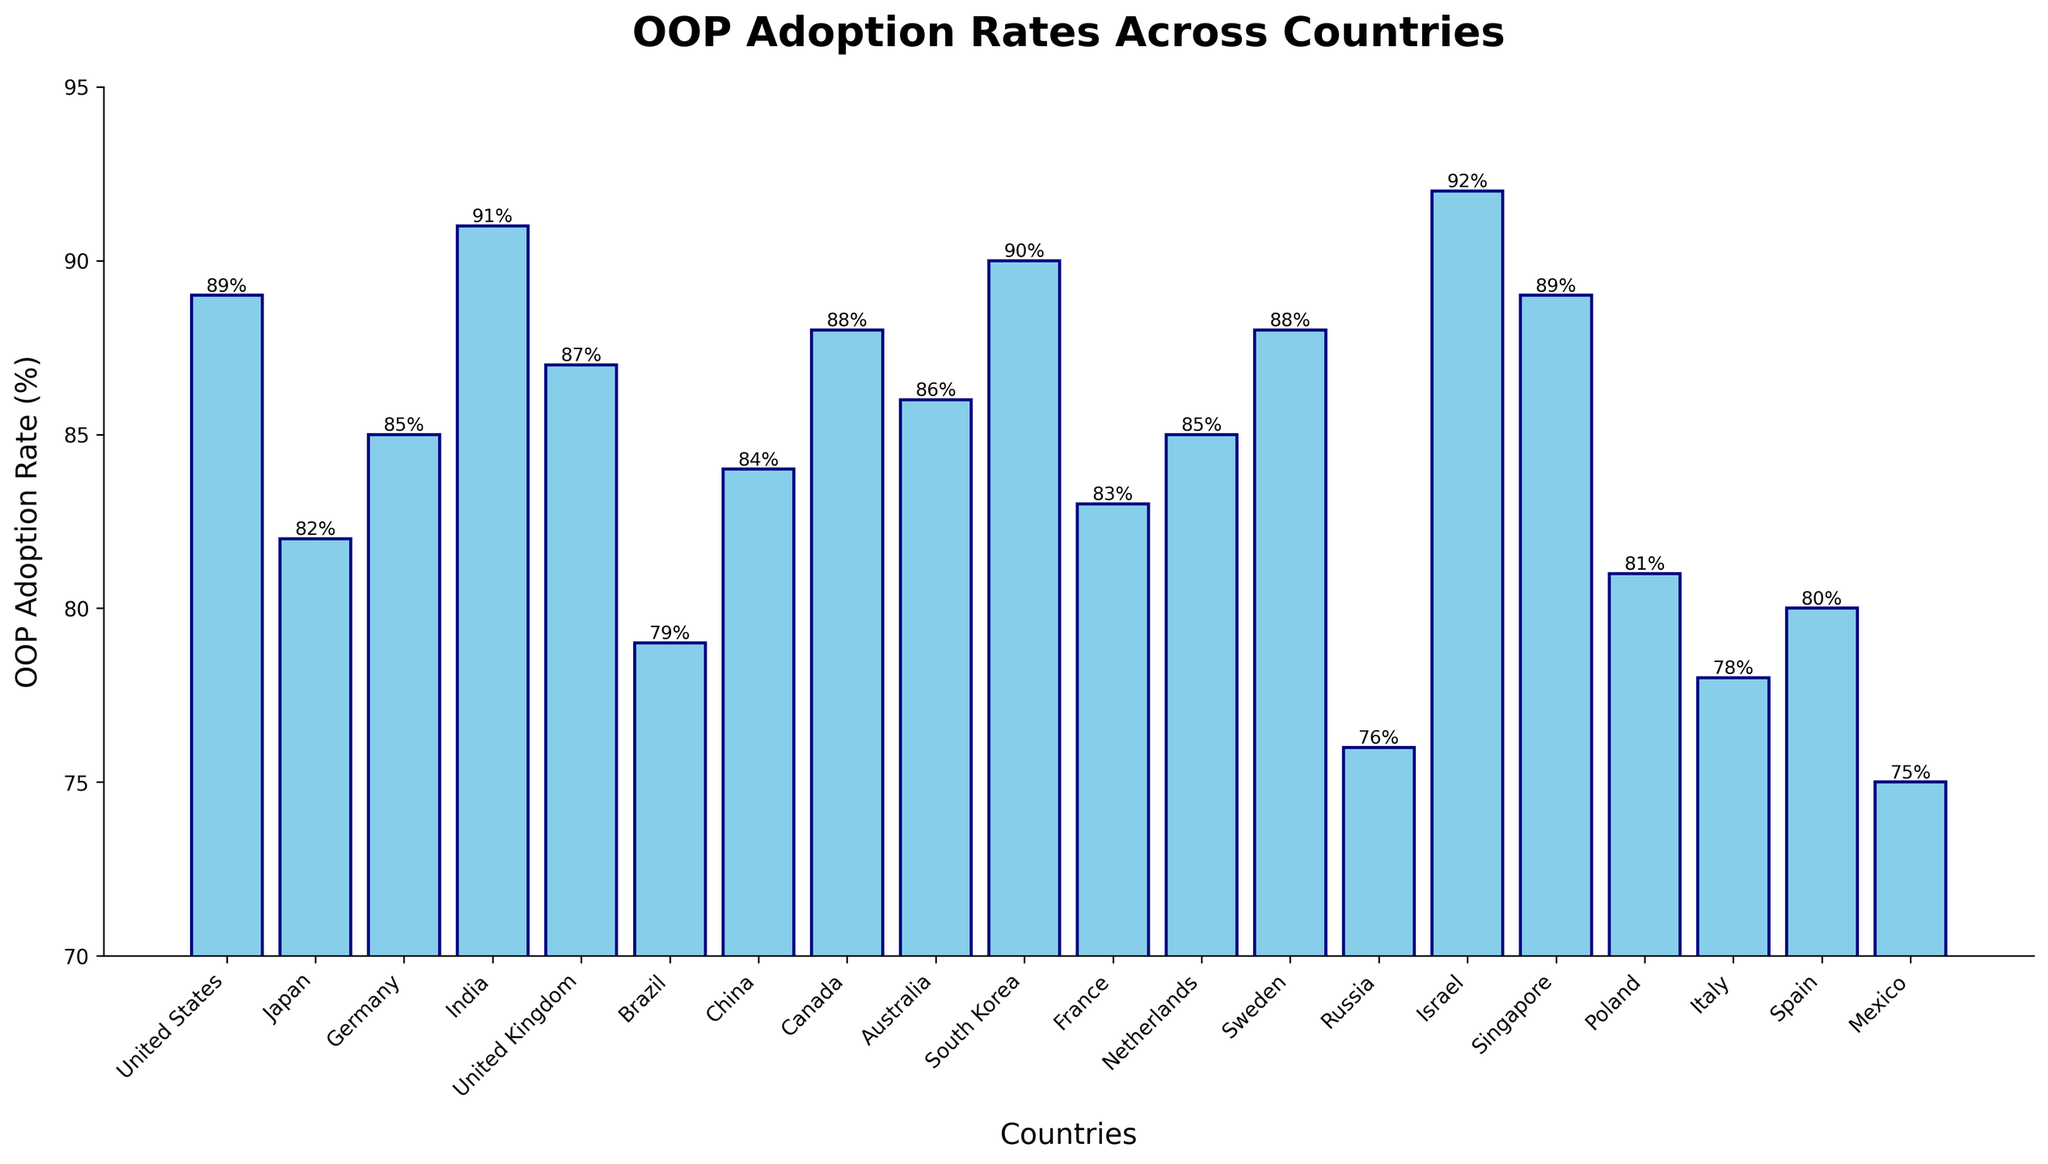Which country has the highest adoption rate of OOP? By looking at the height of the bars, the country with the tallest bar represents the highest adoption rate. Israel's bar is the tallest.
Answer: Israel Which two countries have the exact same OOP adoption rate? By observing the bars and their labeled heights, Singapore and the United States both have an adoption rate of 89%.
Answer: Singapore and United States What is the average OOP adoption rate for United States, Japan, and Germany? Sum the OOP adoption rates for the United States (89%), Japan (82%), and Germany (85%), then divide by the number of countries: (89 + 82 + 85) / 3 = 85.33%.
Answer: 85.33% Which country has a higher adoption rate, France or Canada? By directly comparing the heights of the bars, France has an adoption rate of 83%, whereas Canada has 88%. Therefore, Canada has a higher adoption rate.
Answer: Canada What's the difference in adoption rates between the country with the highest rate and the country with the lowest rate? Identify the highest and lowest rates: Israel (92%) and Mexico (75%). Subtract the lowest from the highest: 92 - 75 = 17%.
Answer: 17% Which countries have an adoption rate lower than 80%? Identify bars with heights less than 80%. The countries are Brazil (79%), Italy (78%), Mexico (75%), and Russia (76%).
Answer: Brazil, Italy, Mexico, Russia What is the median OOP adoption rate across all countries? Arrange all adoption rates in ascending order: 75, 76, 78, 79, 80, 81, 82, 83, 84, 85, 85, 86, 87, 88, 88, 89, 89, 90, 91, 92. The median is the average of the 10th and 11th values: (85 + 85) / 2 = 85%.
Answer: 85% How many countries have an OOP adoption rate greater than 85%? Count the bars above the 85% mark. The countries are United States, India, United Kingdom, Canada, Australia, South Korea, Israel, and Singapore. This makes 8 countries.
Answer: 8 Which country has an adoption rate closest to the average adoption rate of all 20 countries? Calculate the average adoption rate: sum of all rates divided by 20 = (1724/20) = 86.2%. The closest country is Australia with 86%.
Answer: Australia 